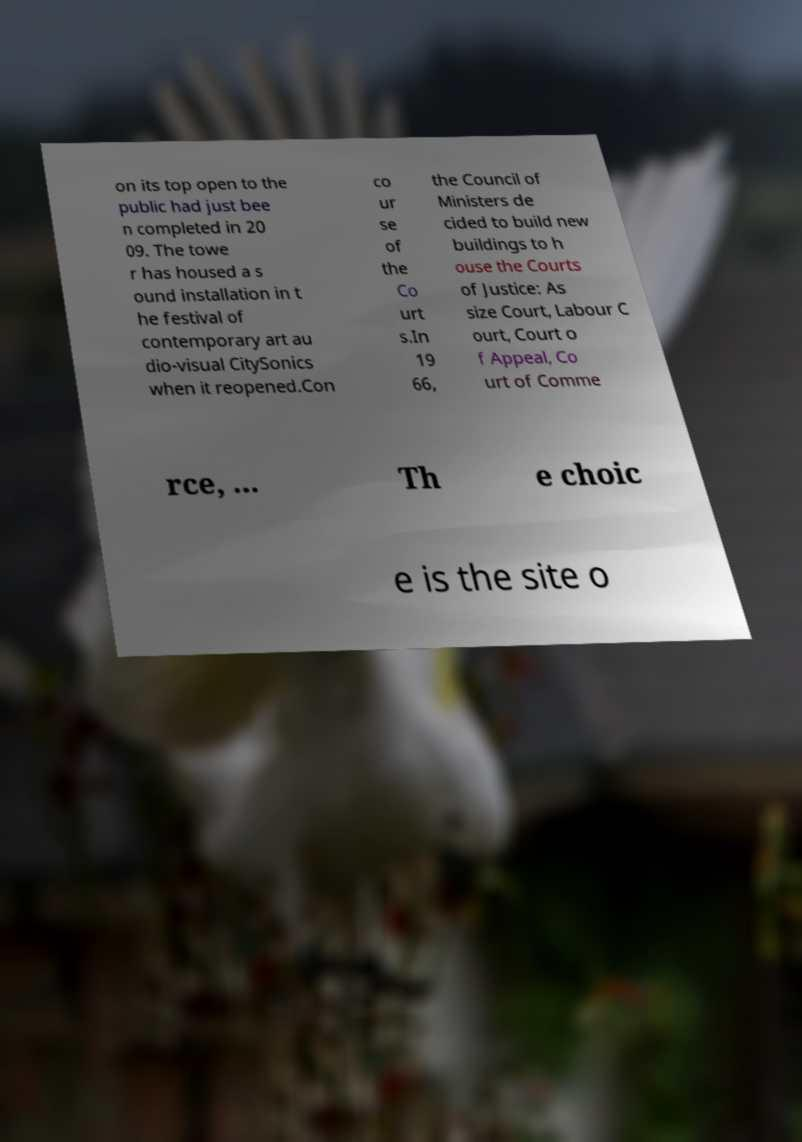Could you extract and type out the text from this image? on its top open to the public had just bee n completed in 20 09. The towe r has housed a s ound installation in t he festival of contemporary art au dio-visual CitySonics when it reopened.Con co ur se of the Co urt s.In 19 66, the Council of Ministers de cided to build new buildings to h ouse the Courts of Justice: As size Court, Labour C ourt, Court o f Appeal, Co urt of Comme rce, ... Th e choic e is the site o 